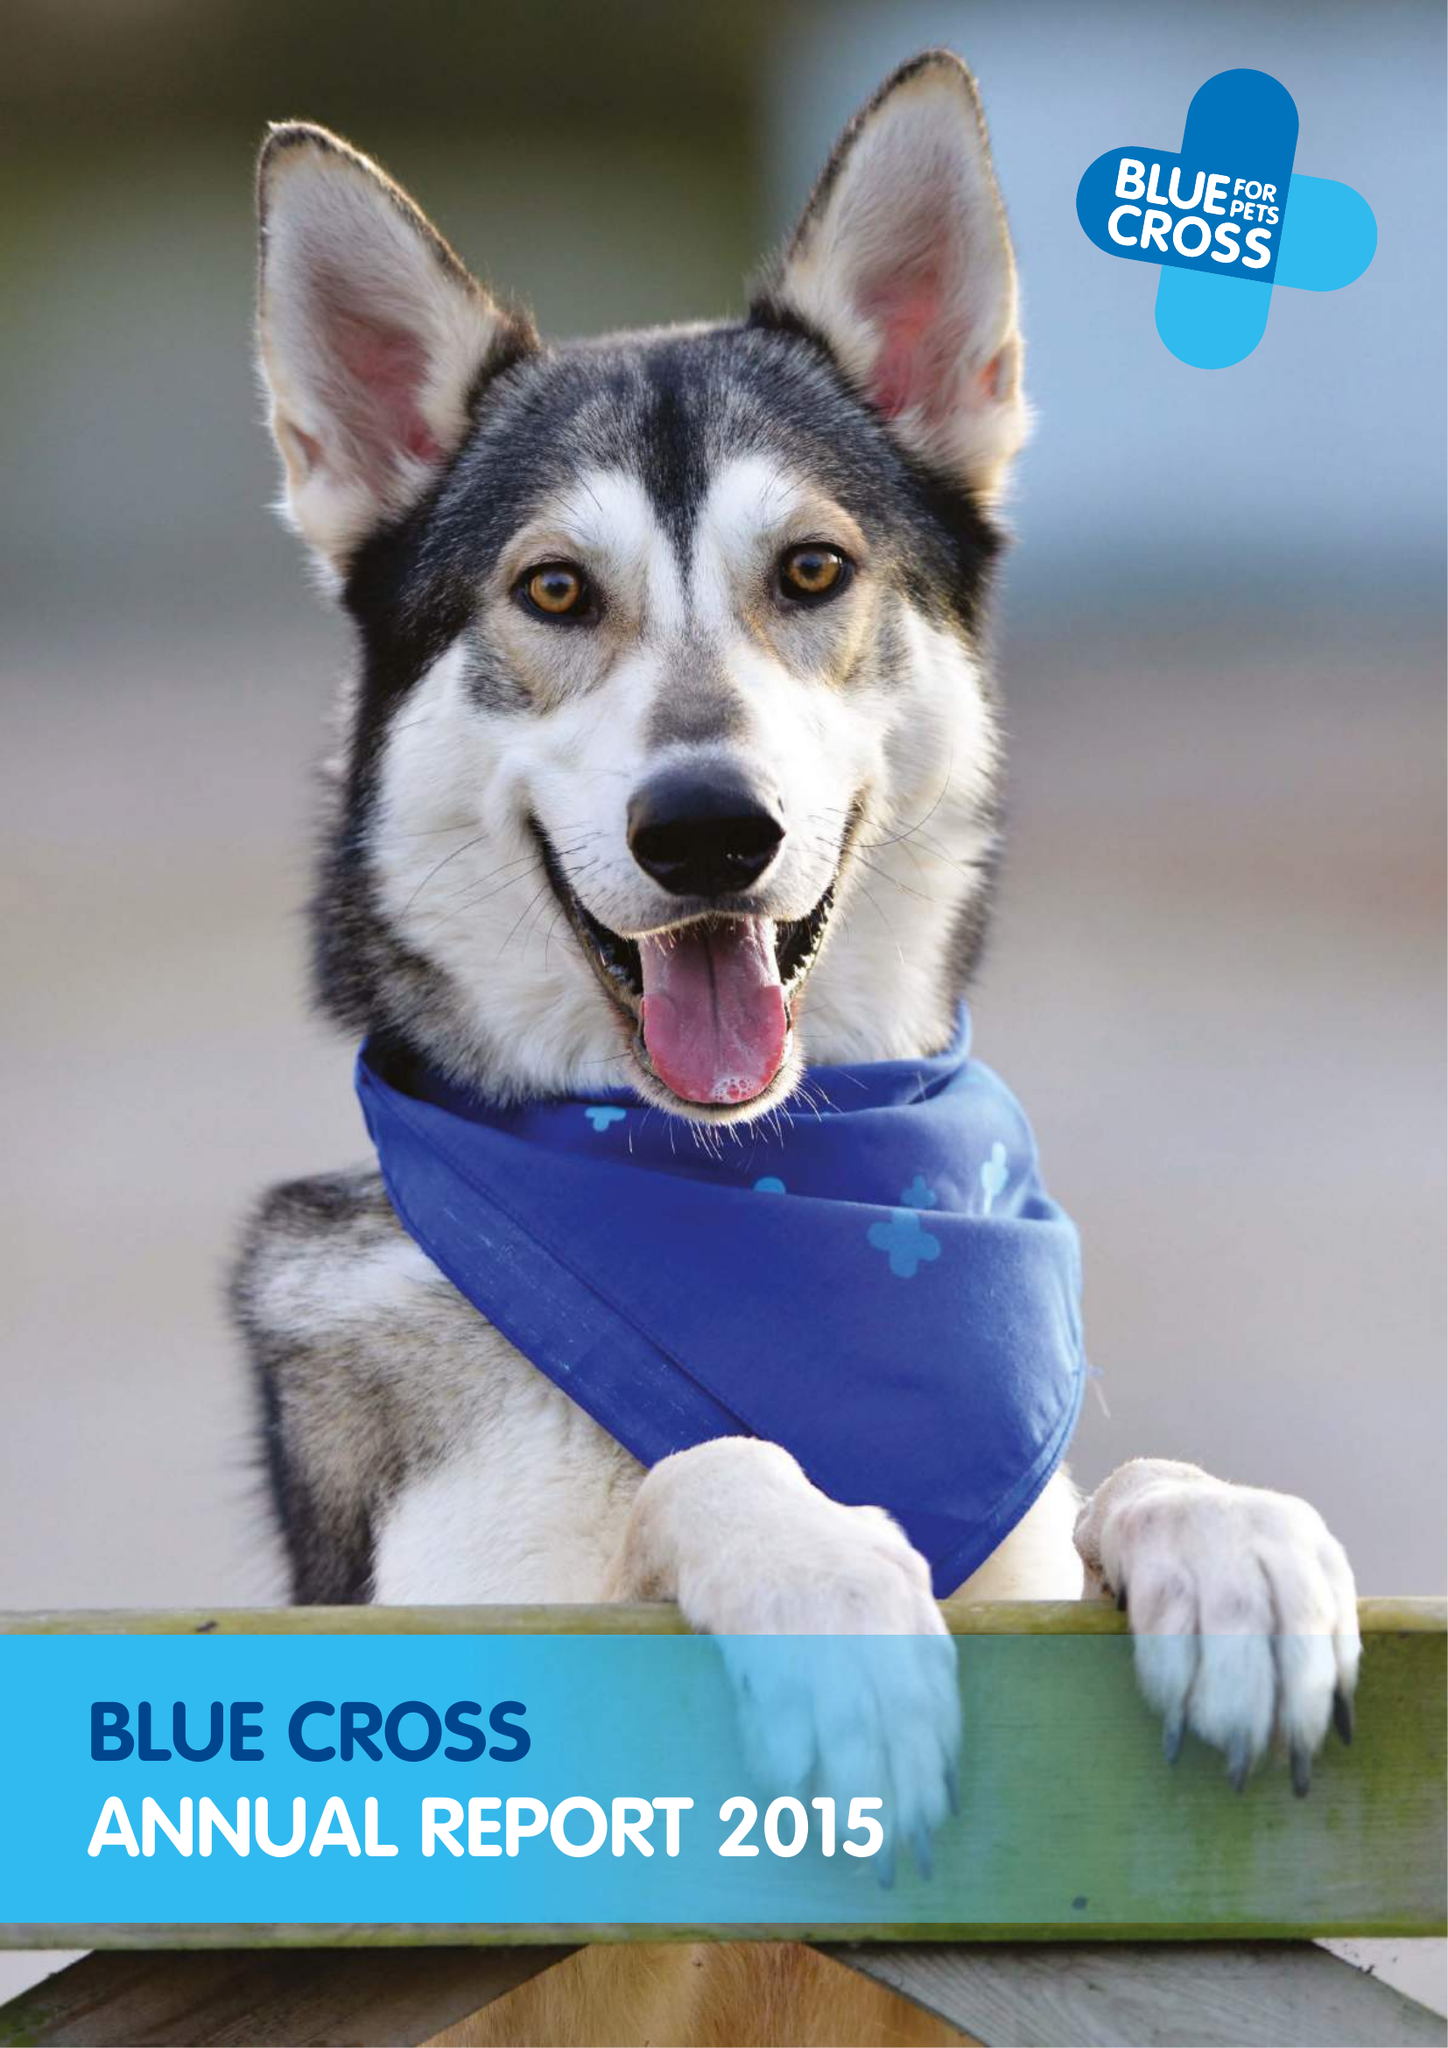What is the value for the income_annually_in_british_pounds?
Answer the question using a single word or phrase. 34158000.00 